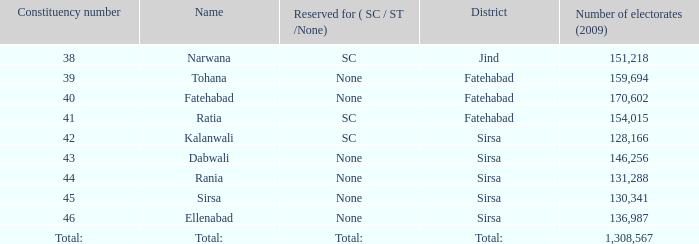Which Number of electorates (2009) has a Constituency number of 46? 136987.0. 